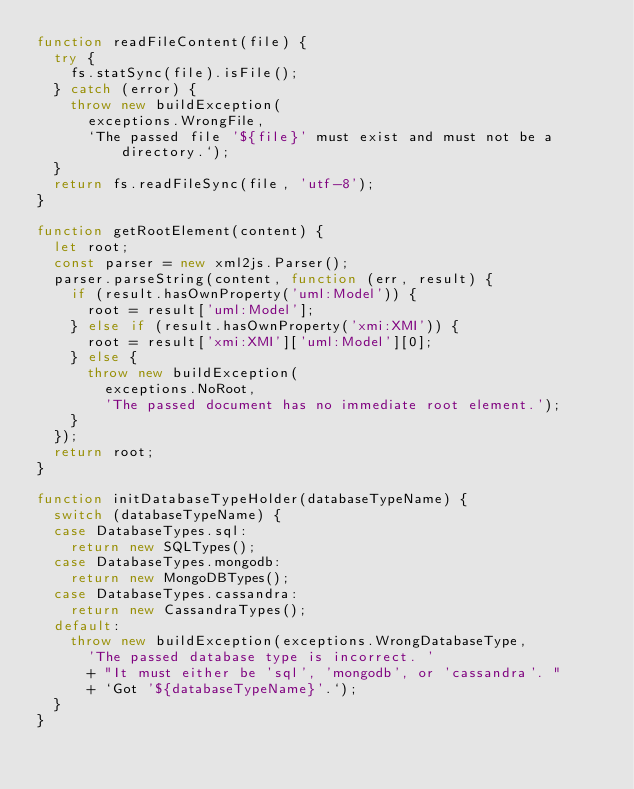<code> <loc_0><loc_0><loc_500><loc_500><_JavaScript_>function readFileContent(file) {
  try {
    fs.statSync(file).isFile();
  } catch (error) {
    throw new buildException(
      exceptions.WrongFile,
      `The passed file '${file}' must exist and must not be a directory.`);
  }
  return fs.readFileSync(file, 'utf-8');
}

function getRootElement(content) {
  let root;
  const parser = new xml2js.Parser();
  parser.parseString(content, function (err, result) {
    if (result.hasOwnProperty('uml:Model')) {
      root = result['uml:Model'];
    } else if (result.hasOwnProperty('xmi:XMI')) {
      root = result['xmi:XMI']['uml:Model'][0];
    } else {
      throw new buildException(
        exceptions.NoRoot,
        'The passed document has no immediate root element.');
    }
  });
  return root;
}

function initDatabaseTypeHolder(databaseTypeName) {
  switch (databaseTypeName) {
  case DatabaseTypes.sql:
    return new SQLTypes();
  case DatabaseTypes.mongodb:
    return new MongoDBTypes();
  case DatabaseTypes.cassandra:
    return new CassandraTypes();
  default:
    throw new buildException(exceptions.WrongDatabaseType,
      'The passed database type is incorrect. '
      + "It must either be 'sql', 'mongodb', or 'cassandra'. "
      + `Got '${databaseTypeName}'.`);
  }
}
</code> 